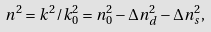Convert formula to latex. <formula><loc_0><loc_0><loc_500><loc_500>n ^ { 2 } = k ^ { 2 } / k ^ { 2 } _ { 0 } = n _ { 0 } ^ { 2 } - \Delta n _ { d } ^ { 2 } - \Delta n _ { s } ^ { 2 } ,</formula> 